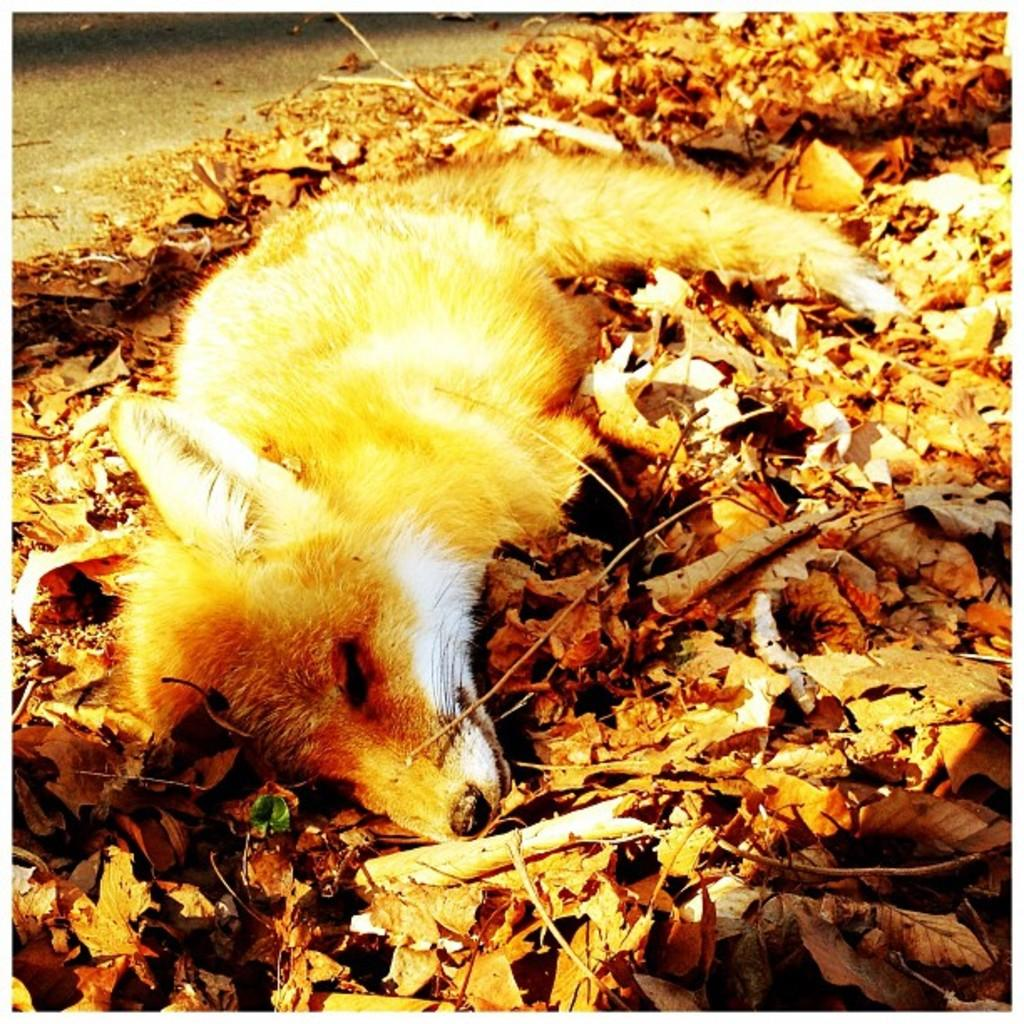What type of animal can be seen in the image? There is a dog in the image. What is the dog doing in the image? The dog is lying on a surface. What can be found on the surface where the dog is lying? Dry leaves and sticks are present on the surface. What is visible in the background of the image? There is a road in the background of the image. What is the dog's opinion on the governor's recent policy decisions in the image? There is no indication in the image that the dog has any opinion on the governor's recent policy decisions, as the dog is simply lying on a surface. 